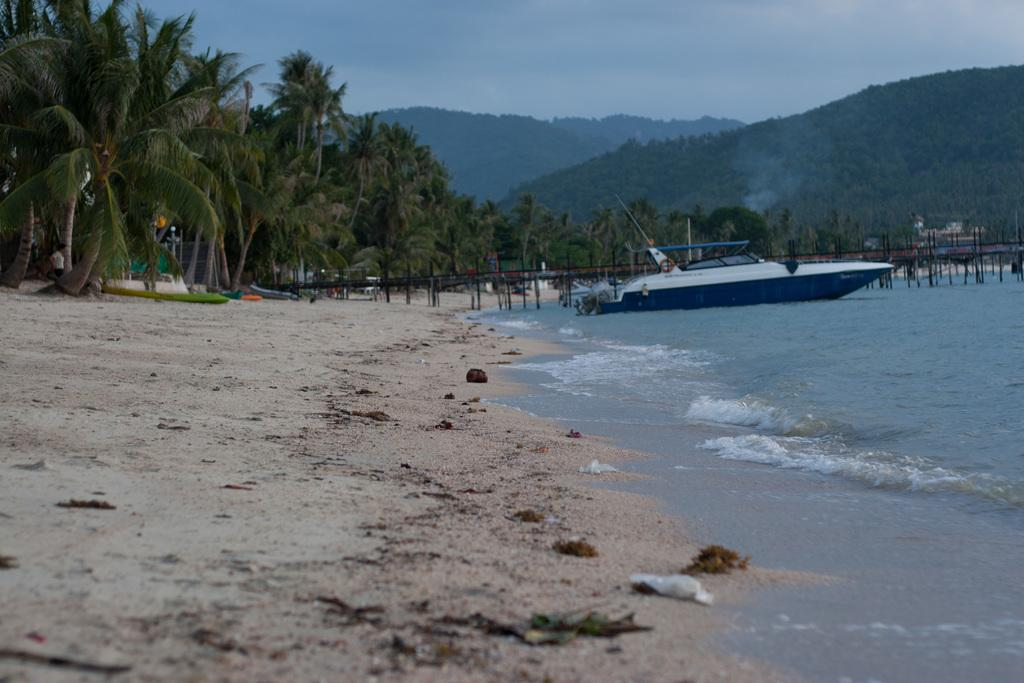What is the main subject of the image? The main subject of the image is a ship on the water. What other structures or objects can be seen in the image? There is a bridge in the image. What type of natural scenery is visible in the background? Trees and the sky are visible in the background. What type of silk is used to make the collar of the ship in the image? There is no mention of silk or a collar in the image, as it features a ship on the water and a bridge in the background. 